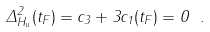Convert formula to latex. <formula><loc_0><loc_0><loc_500><loc_500>\Delta _ { H _ { u } } ^ { 2 } ( t _ { F } ) = c _ { 3 } + 3 c _ { 1 } ( t _ { F } ) = 0 \ .</formula> 